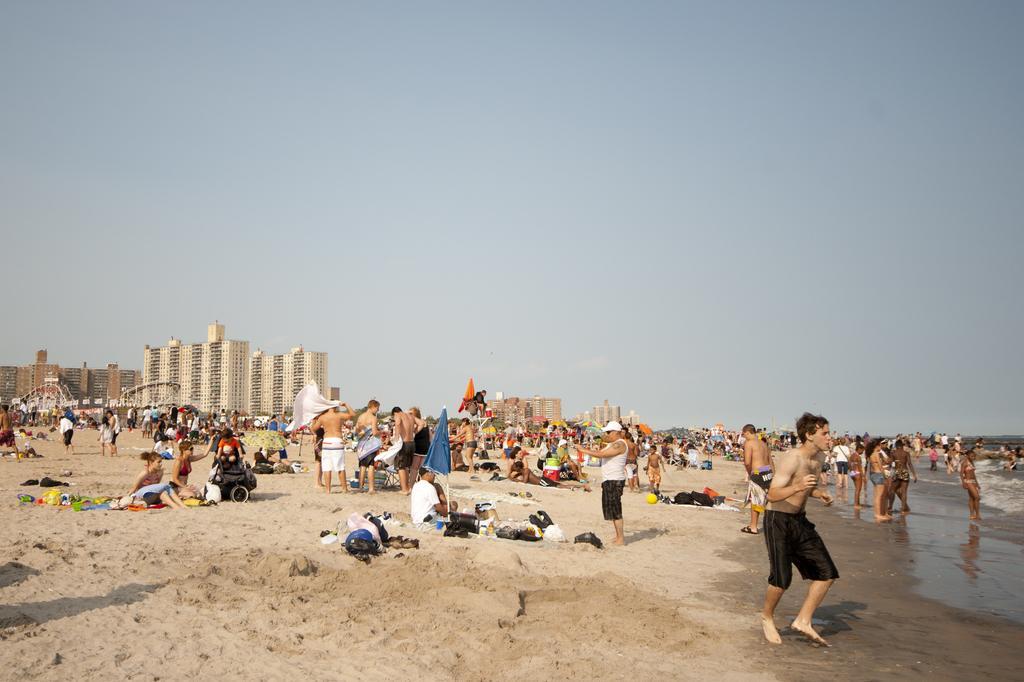How would you summarize this image in a sentence or two? In this image I can see the group of people with different color dresses. To the side of these people I can see the water. There are many objects on the sand. In the background I can see many buildings and the sky. 